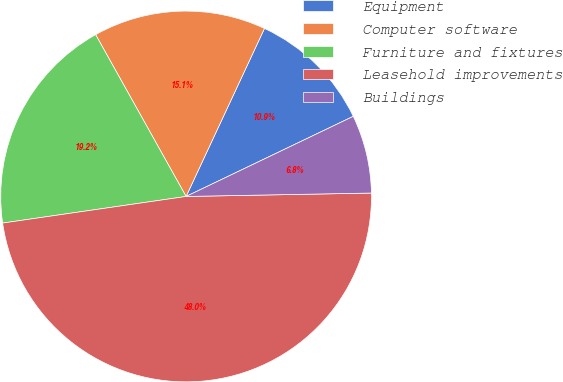<chart> <loc_0><loc_0><loc_500><loc_500><pie_chart><fcel>Equipment<fcel>Computer software<fcel>Furniture and fixtures<fcel>Leasehold improvements<fcel>Buildings<nl><fcel>10.94%<fcel>15.06%<fcel>19.18%<fcel>48.0%<fcel>6.82%<nl></chart> 